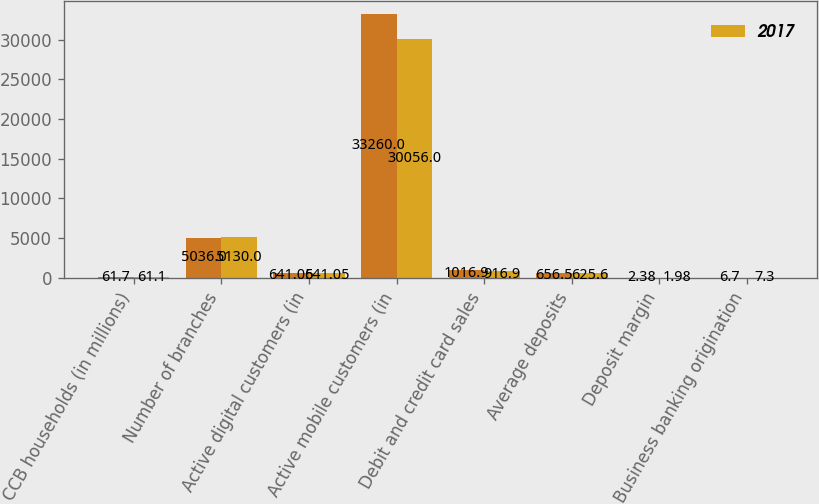Convert chart to OTSL. <chart><loc_0><loc_0><loc_500><loc_500><stacked_bar_chart><ecel><fcel>CCB households (in millions)<fcel>Number of branches<fcel>Active digital customers (in<fcel>Active mobile customers (in<fcel>Debit and credit card sales<fcel>Average deposits<fcel>Deposit margin<fcel>Business banking origination<nl><fcel>nan<fcel>61.7<fcel>5036<fcel>641.05<fcel>33260<fcel>1016.9<fcel>656.5<fcel>2.38<fcel>6.7<nl><fcel>2017<fcel>61.1<fcel>5130<fcel>641.05<fcel>30056<fcel>916.9<fcel>625.6<fcel>1.98<fcel>7.3<nl></chart> 